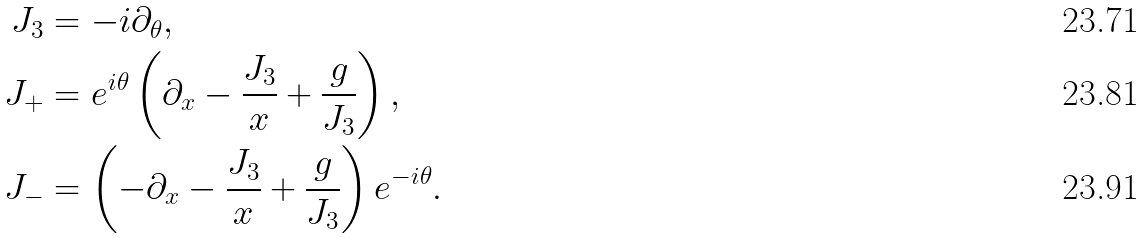Convert formula to latex. <formula><loc_0><loc_0><loc_500><loc_500>J _ { 3 } & = - i \partial _ { \theta } , \\ J _ { + } & = e ^ { i \theta } \left ( \partial _ { x } - \frac { J _ { 3 } } { x } + \frac { g } { J _ { 3 } } \right ) , \\ J _ { - } & = \left ( - \partial _ { x } - \frac { J _ { 3 } } { x } + \frac { g } { J _ { 3 } } \right ) e ^ { - i \theta } .</formula> 